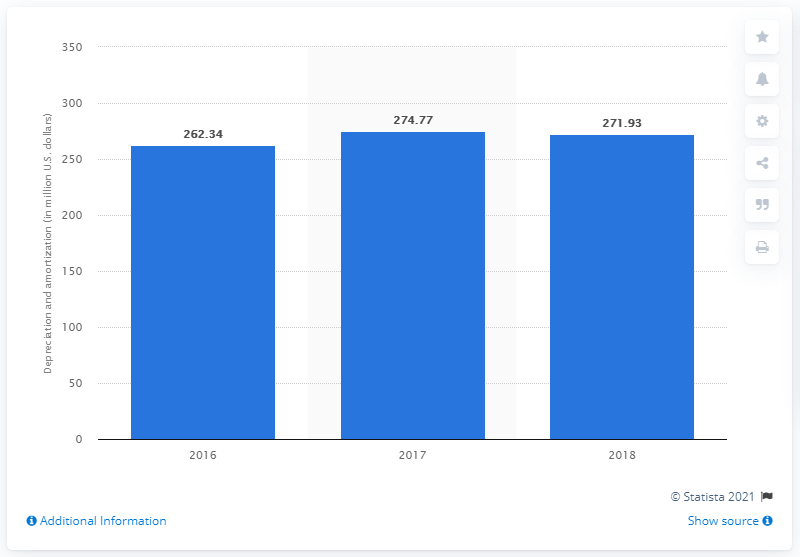Point out several critical features in this image. Mattel incurred depreciation and amortization of $271.93 in 2018. 